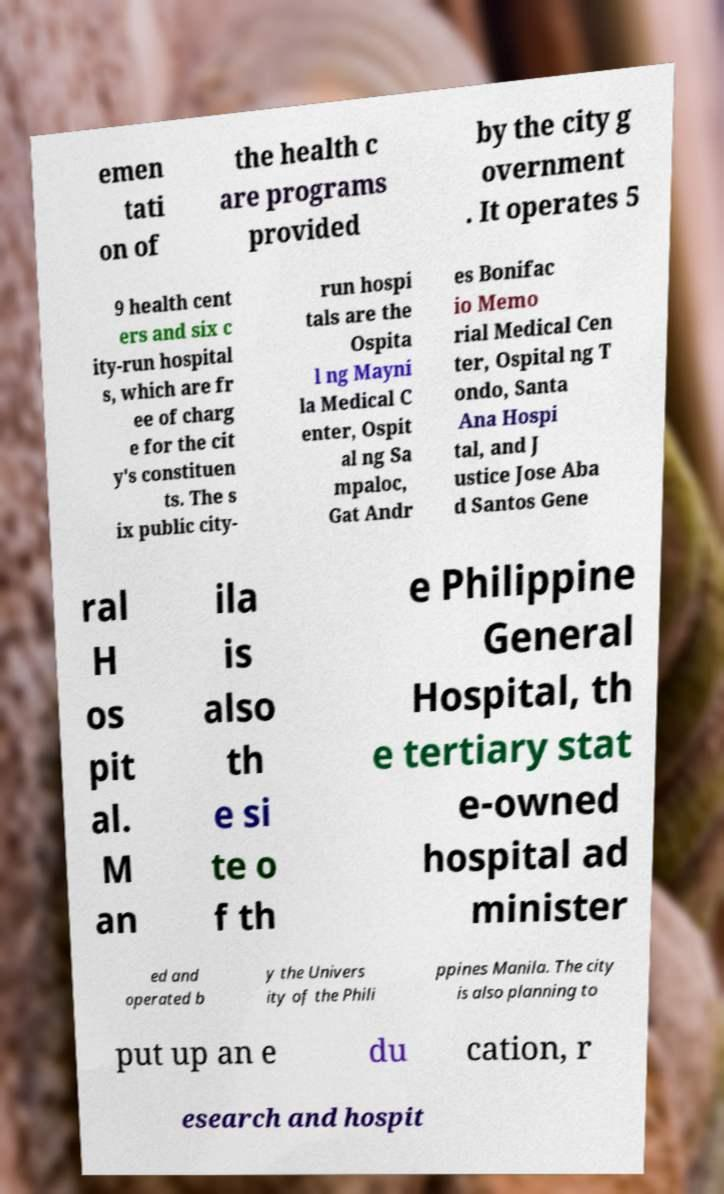Please read and relay the text visible in this image. What does it say? emen tati on of the health c are programs provided by the city g overnment . It operates 5 9 health cent ers and six c ity-run hospital s, which are fr ee of charg e for the cit y's constituen ts. The s ix public city- run hospi tals are the Ospita l ng Mayni la Medical C enter, Ospit al ng Sa mpaloc, Gat Andr es Bonifac io Memo rial Medical Cen ter, Ospital ng T ondo, Santa Ana Hospi tal, and J ustice Jose Aba d Santos Gene ral H os pit al. M an ila is also th e si te o f th e Philippine General Hospital, th e tertiary stat e-owned hospital ad minister ed and operated b y the Univers ity of the Phili ppines Manila. The city is also planning to put up an e du cation, r esearch and hospit 